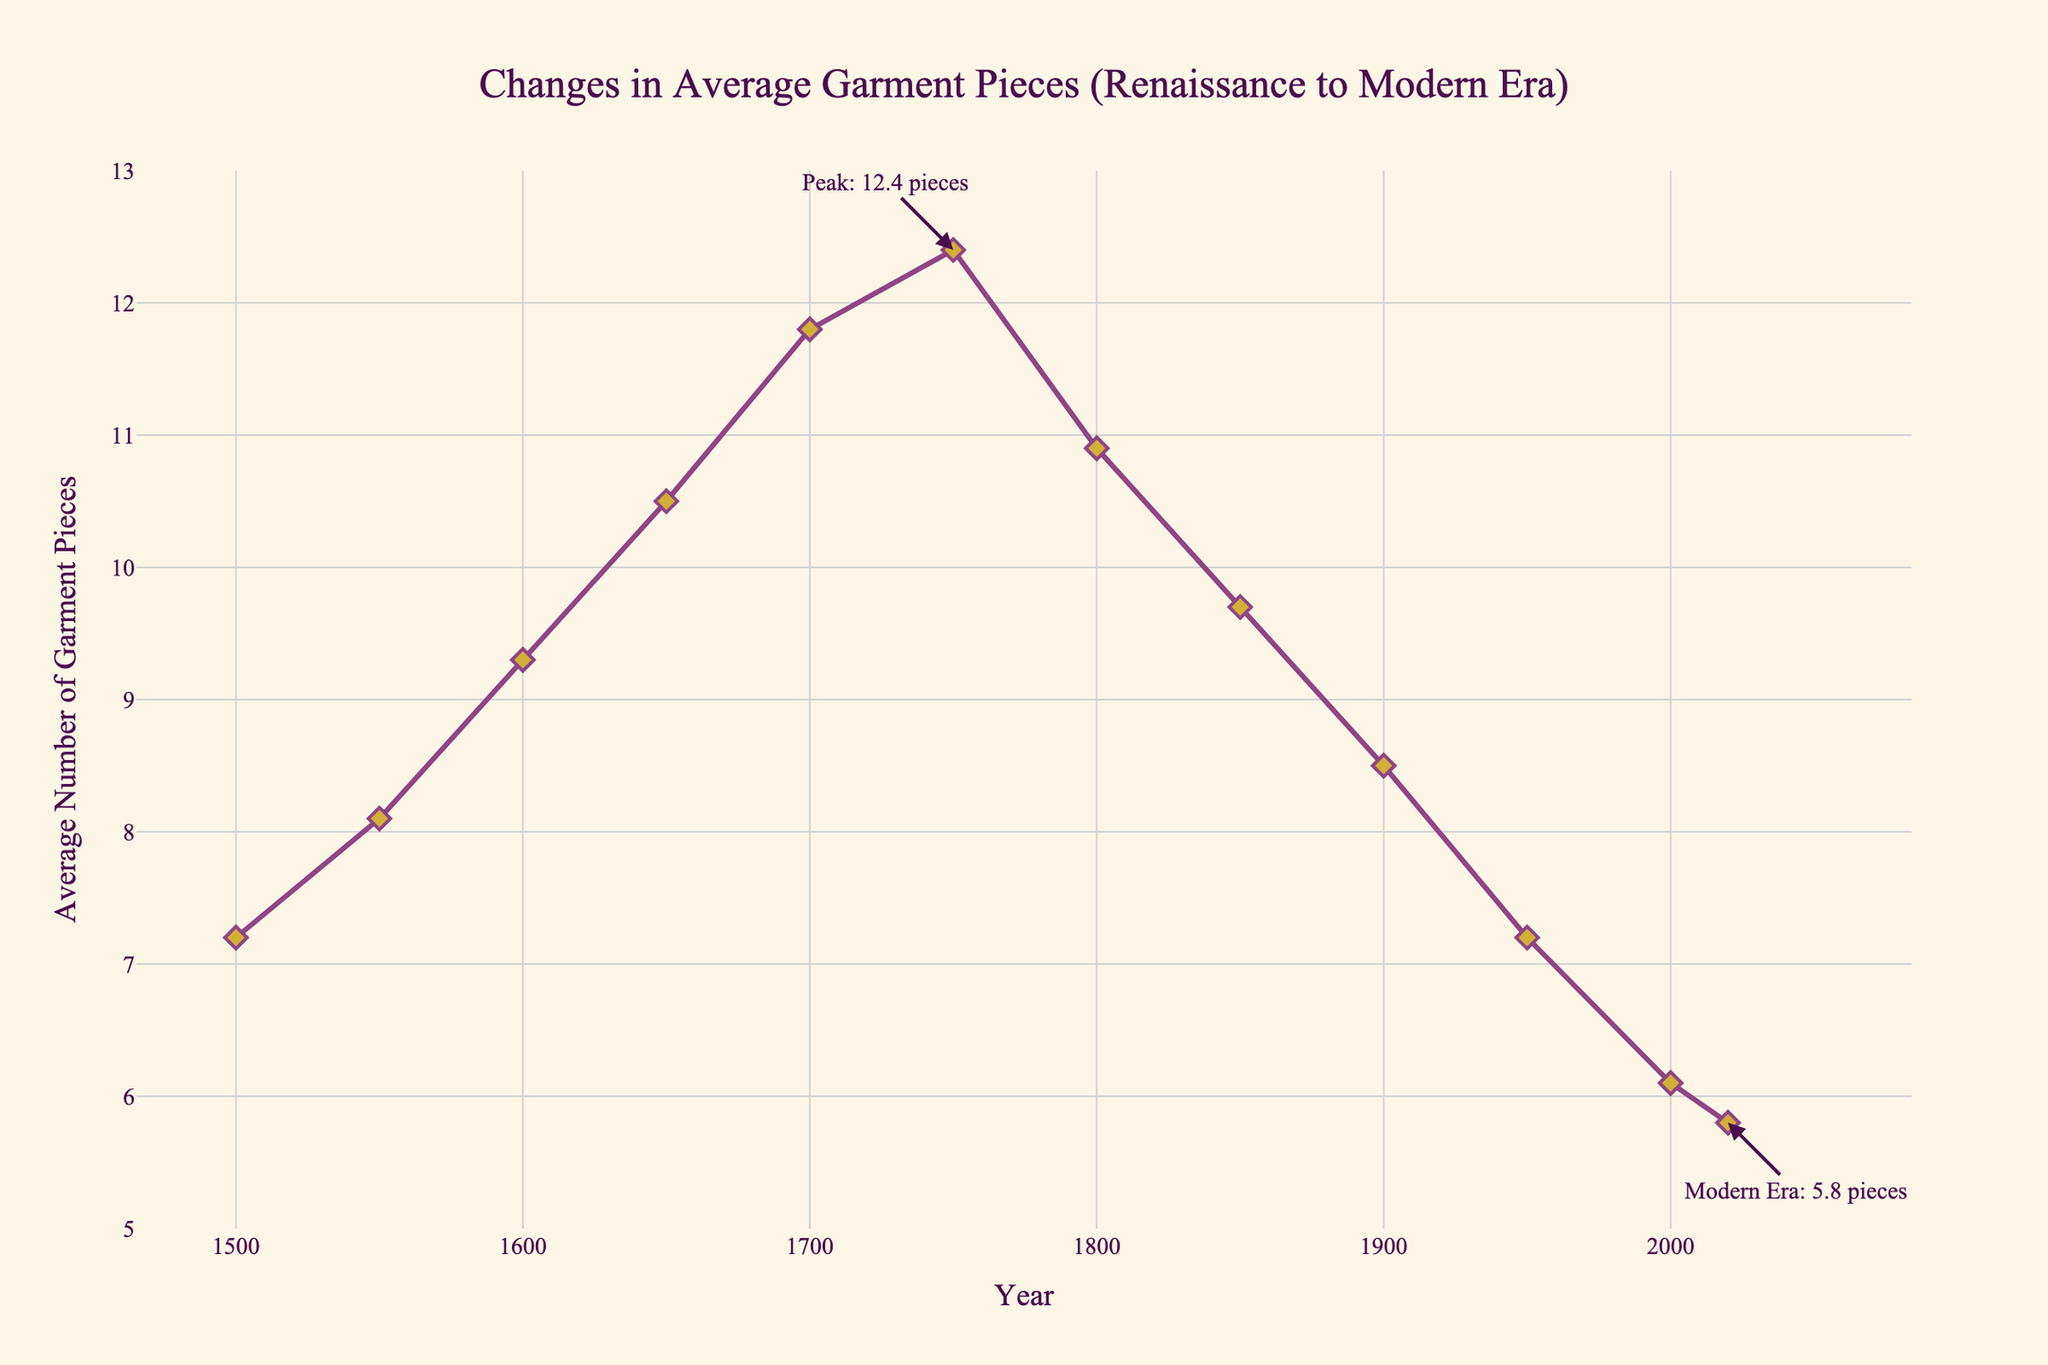What's the peak value of average garment pieces in the data? The line chart annotates the peak value at the point around 1750, where the average number of garment pieces is labeled as "12.4 pieces".
Answer: 12.4 pieces How did the average number of garment pieces change from 1600 to 1650? From the visual data points on the chart, in 1600 the average number of garment pieces is around 9.3, and in 1650 it increases to about 10.5. To compute the change: 10.5 - 9.3 = 1.2
Answer: Increased by 1.2 In which period did the average number of garment pieces drop the most? To find the period with the largest drop, look for the steepest downward slope. From 1750 (12.4 pieces) to 1800 (10.9 pieces), the decrease is 12.4 - 10.9 = 1.5. Checking other periods, this is the largest drop.
Answer: Between 1750 and 1800 Which era has the least number of average garment pieces, and what is the number? According to the chart, the modern era (2020) has the least number of average garment pieces, annotated explicitly as "5.8 pieces".
Answer: Modern era with 5.8 pieces Compare the average garment pieces in the year 1500 and 1950 The chart shows that in 1500 there are 7.2 pieces and in 1950 it is also 7.2 pieces. Therefore, the average number of garment pieces in both years is the same.
Answer: Equal in both years (7.2 pieces) Which year had an equal number of garment pieces as the number of pieces in 1500? From observing the chart, both the years 1500 and 1950 have 7.2 garment pieces.
Answer: 1950 What is the average number of garment pieces across all the years on the chart? To find the average, add all the data points (7.2 + 8.1 + 9.3 + 10.5 + 11.8 + 12.4 + 10.9 + 9.7 + 8.5 + 7.2 + 6.1 + 5.8) and divide by the total number of points (12). Summing gives 107.5; then, 107.5 / 12 ≈ 8.96.
Answer: 8.96 pieces Which two consecutive periods show the smallest change in the number of garment pieces? By comparing the differences between consecutive data points: 8.1 - 7.2, 9.3 - 8.1, 10.5 - 9.3, ... 5.8 - 6.1, the smallest change occurs between 2000 and 2020: 6.1 - 5.8 = 0.3.
Answer: 2000 to 2020 with a change of 0.3 pieces What is the trend of average garment pieces from 1500 to 1700? The trajectory from 1500 to 1700 shows a gradual increase in the average number of garment pieces: from 7.2 to 8.1, 9.3, 10.5, and finally 11.8 in 1700.
Answer: Increasing trend 